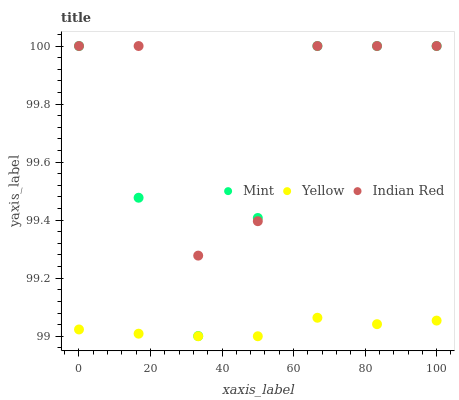Does Yellow have the minimum area under the curve?
Answer yes or no. Yes. Does Indian Red have the maximum area under the curve?
Answer yes or no. Yes. Does Indian Red have the minimum area under the curve?
Answer yes or no. No. Does Yellow have the maximum area under the curve?
Answer yes or no. No. Is Yellow the smoothest?
Answer yes or no. Yes. Is Indian Red the roughest?
Answer yes or no. Yes. Is Indian Red the smoothest?
Answer yes or no. No. Is Yellow the roughest?
Answer yes or no. No. Does Yellow have the lowest value?
Answer yes or no. Yes. Does Indian Red have the lowest value?
Answer yes or no. No. Does Indian Red have the highest value?
Answer yes or no. Yes. Does Yellow have the highest value?
Answer yes or no. No. Is Yellow less than Indian Red?
Answer yes or no. Yes. Is Mint greater than Yellow?
Answer yes or no. Yes. Does Indian Red intersect Mint?
Answer yes or no. Yes. Is Indian Red less than Mint?
Answer yes or no. No. Is Indian Red greater than Mint?
Answer yes or no. No. Does Yellow intersect Indian Red?
Answer yes or no. No. 